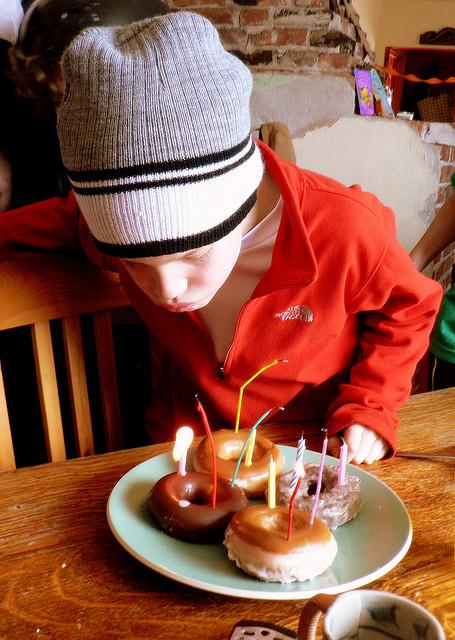What is the boy about to do? Please explain your reasoning. blow candle. The boy will blow the candles. 